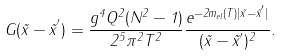<formula> <loc_0><loc_0><loc_500><loc_500>G ( \vec { x } - { \vec { x } } ^ { ^ { \prime } } ) = \frac { g ^ { 4 } Q ^ { 2 } ( N ^ { 2 } - 1 ) } { 2 ^ { 5 } \pi ^ { 2 } T ^ { 2 } } \frac { e ^ { - 2 m _ { e l } ( T ) | \vec { x } - { \vec { x } } ^ { ^ { \prime } } | } } { ( \vec { x } - { \vec { x } } ^ { ^ { \prime } } ) ^ { 2 } } .</formula> 